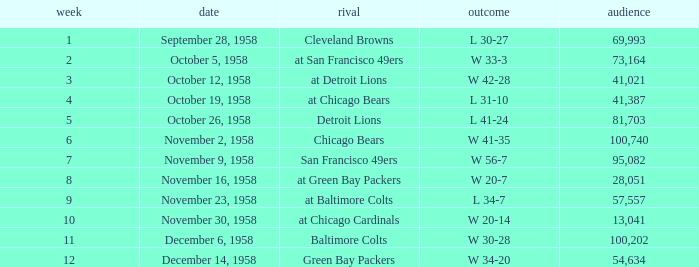What was the higest attendance on November 9, 1958? 95082.0. 